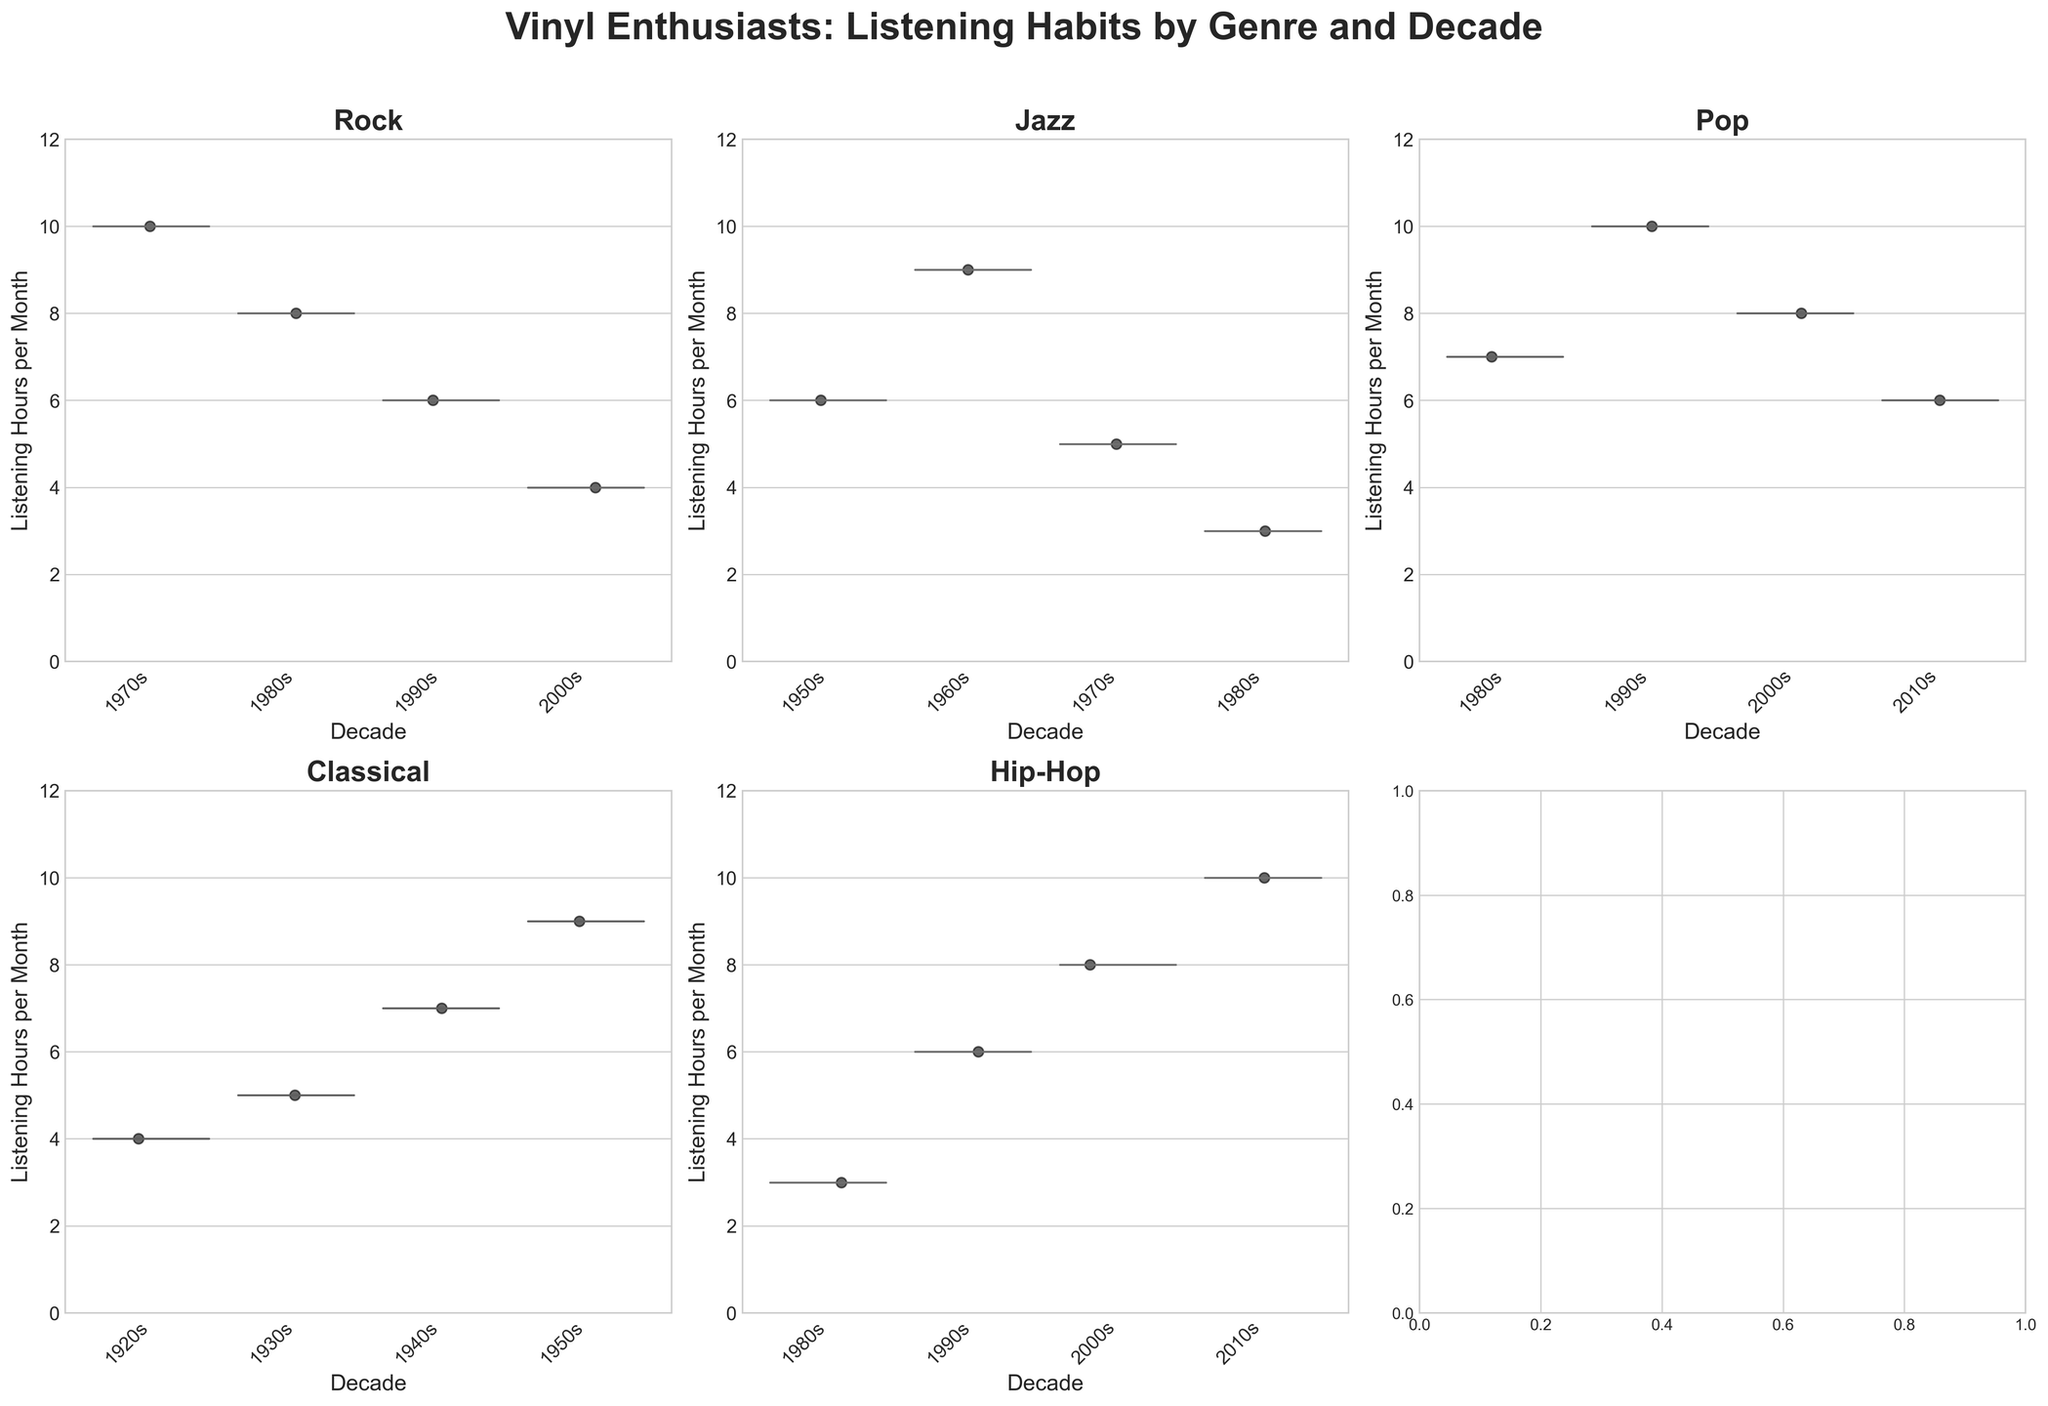What is the title of the figure? The title of the figure is presented at the top center of the plot with large, bold font. It gives an overview of what the whole figure represents.
Answer: Vinyl Enthusiasts: Listening Habits by Genre and Decade What decade shows the highest listening hours per month for Rock? By observing the Rock subplot, the 1970s show the highest listening hours per month with a value of 10.
Answer: 1970s How many genres are displayed in the figure? Each subplot represents a different genre, which can be counted. There are six subplots, hence six genres displayed.
Answer: 6 Which genre has the widest spread of listening hours distribution? The spread of listening hours can be determined by looking at the size of the violin plots. Classical appears to have the widest spread across different decades.
Answer: Classical Comparing the 1980s, which genre has more listening hours per month, Jazz or Hip-Hop? Looking at the 1980s for both Jazz and Hip-Hop subplots, Jazz has 3 listening hours per month whereas Hip-Hop has 3 listening hours as well.
Answer: Equal Which decade shows the lowest listening hour for Hip-Hop? Examining the Hip-Hop subplot, the 1980s show the lowest listening hours per month with a value of 3.
Answer: 1980s What is the mean listening hours per month for Pop across all displayed decades? To find the mean, sum up the listening hours per month for Pop (7 + 10 + 8 + 6) which equals 31 and divide by the number of data points (4). Mean = 31/4.
Answer: 7.75 Does the listening hour pattern for Pop increase, decrease, or fluctuate across decades? By following the trend line for each represented decade for Pop, we observe a fluctuating pattern with listening hours going from 7, to 10, to 8, then 6.
Answer: Fluctuate Which genre and decade combination has the overall highest listening hours per month? By reviewing all subplots, the 2010s for Hip-Hop show the highest listening hours per month of 10.
Answer: Hip-Hop, 2010s Is there any genre with a consistent listening hour across multiple decades? Checking all subplots, Jazz’s listening hours in the 1980s and Hip-Hop in the 1980s both have 3, showing some consistency.
Answer: Jazz, Hip-Hop 